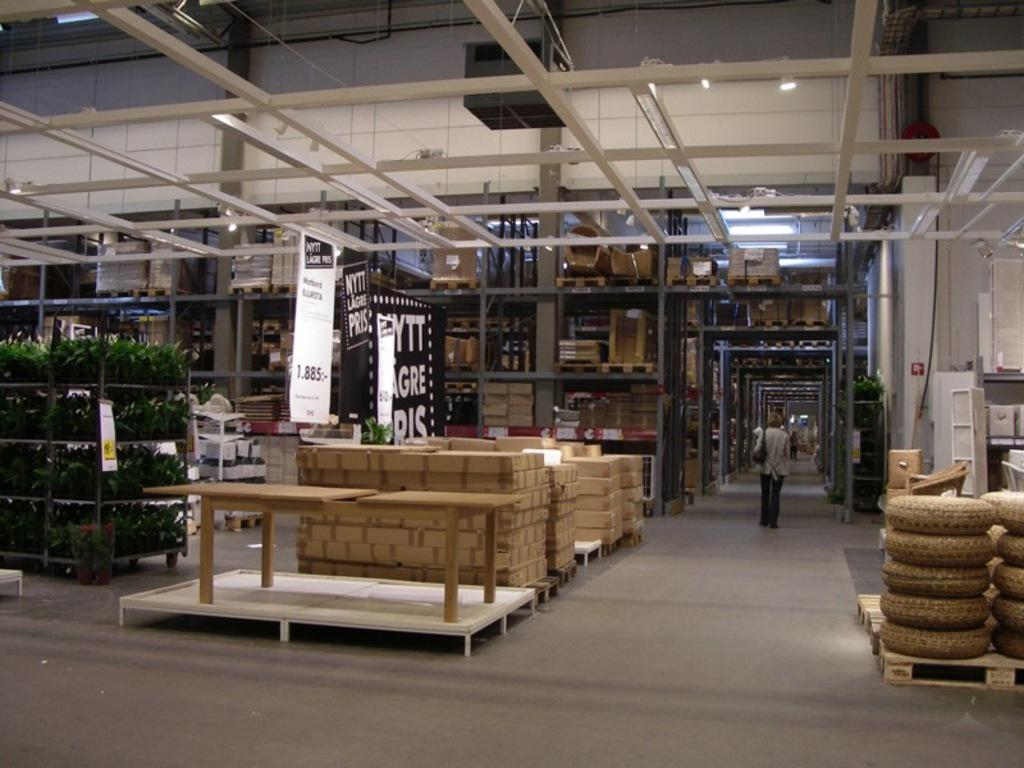What is located on the left side of the image? There are plants in a rack on the left side of the image. What can be seen in the center of the image? There are boxes in the center of the image. What else can be observed in the background of the image? There are other boxes in the background area of the image. What type of jeans are the plants wearing in the image? There are no jeans present in the image, as the subjects are plants. How many family members can be seen in the image? There is no reference to a family or any family members in the image. 